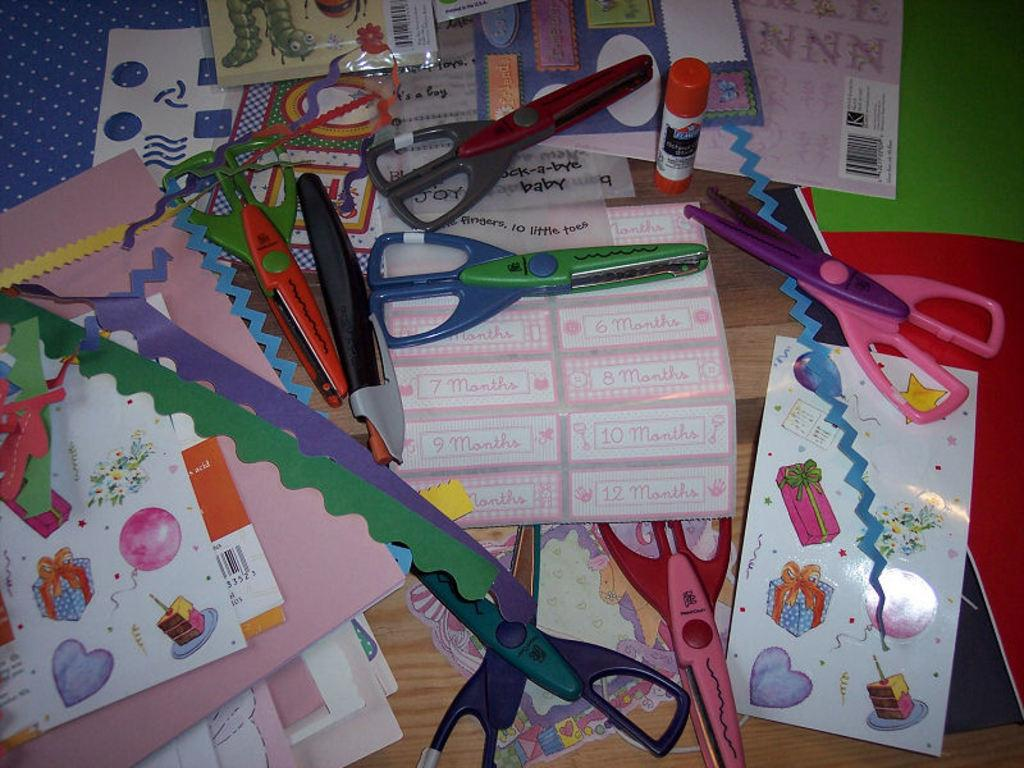What type of materials can be seen in the image? Papers, scissors, a glue stick, and color papers can be seen in the image. What might these materials be used for? These materials might be used for crafting or art projects. Where are these items located in the image? All items are on a table. What type of corn is being served in a bowl in the image? There is no corn or bowl present in the image; it only features papers, scissors, a glue stick, and color papers on a table. 